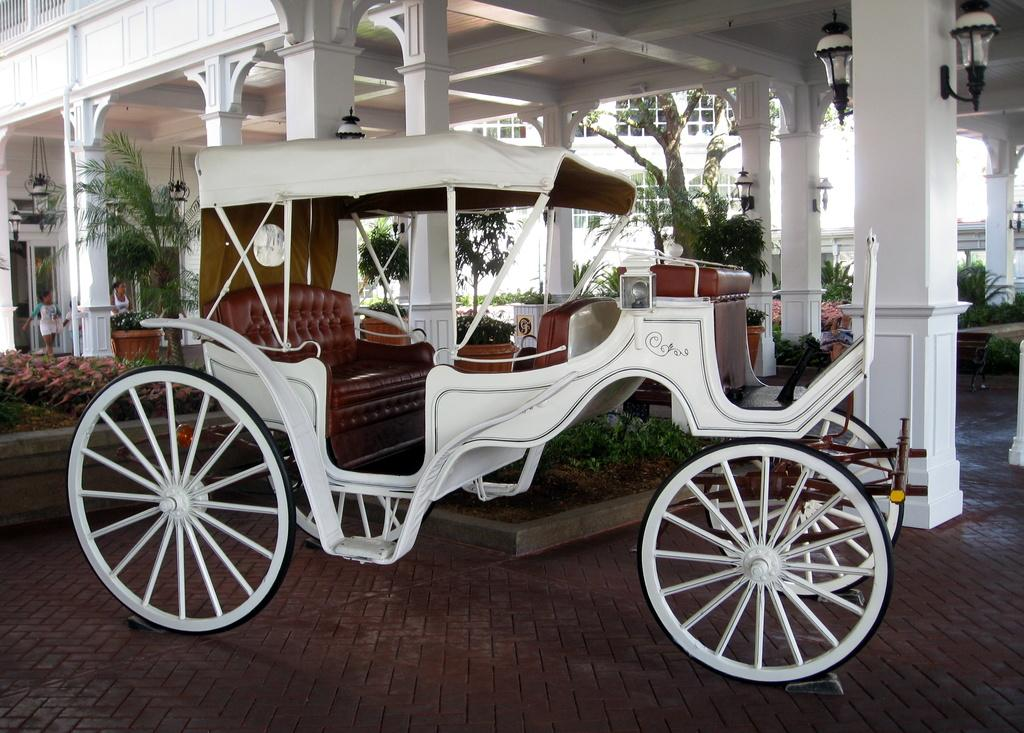What is the main object in the middle of the image? There is a cart in the middle of the image. What can be seen behind the cart? There are plants and trees behind the cart. What is visible in the background of the image? There is a building visible in the background. What is happening in the background of the image? There are people walking in the background. What type of alarm is ringing in the image? There is no alarm present in the image. What kind of stone is used to build the cart in the image? The cart is not made of stone; it is likely made of metal or wood. 